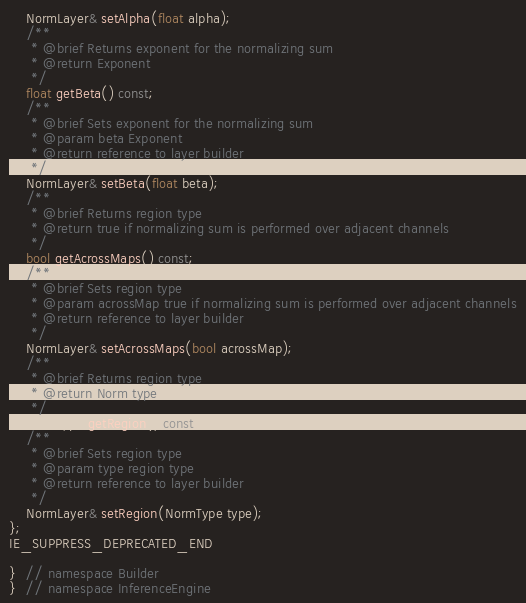Convert code to text. <code><loc_0><loc_0><loc_500><loc_500><_C++_>    NormLayer& setAlpha(float alpha);
    /**
     * @brief Returns exponent for the normalizing sum
     * @return Exponent
     */
    float getBeta() const;
    /**
     * @brief Sets exponent for the normalizing sum
     * @param beta Exponent
     * @return reference to layer builder
     */
    NormLayer& setBeta(float beta);
    /**
     * @brief Returns region type
     * @return true if normalizing sum is performed over adjacent channels
     */
    bool getAcrossMaps() const;
    /**
     * @brief Sets region type
     * @param acrossMap true if normalizing sum is performed over adjacent channels
     * @return reference to layer builder
     */
    NormLayer& setAcrossMaps(bool acrossMap);
    /**
     * @brief Returns region type
     * @return Norm type
     */
    NormType getRegion() const;
    /**
     * @brief Sets region type
     * @param type region type
     * @return reference to layer builder
     */
    NormLayer& setRegion(NormType type);
};
IE_SUPPRESS_DEPRECATED_END

}  // namespace Builder
}  // namespace InferenceEngine
</code> 